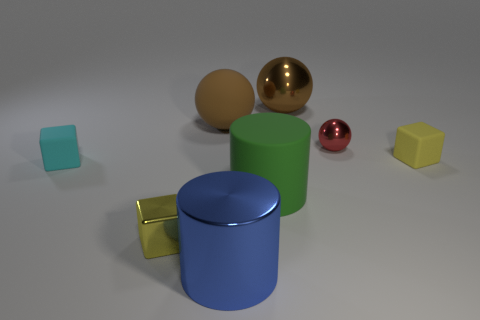Is there a gray metal thing?
Provide a short and direct response. No. There is a thing that is to the right of the blue metal object and in front of the tiny cyan block; what size is it?
Your response must be concise. Large. Is the number of shiny things in front of the big green cylinder greater than the number of tiny yellow rubber things behind the tiny red metallic thing?
Make the answer very short. Yes. What is the size of the rubber object that is the same color as the tiny shiny block?
Offer a terse response. Small. What is the color of the rubber cylinder?
Provide a succinct answer. Green. What color is the large object that is both behind the big metallic cylinder and in front of the small cyan rubber thing?
Your response must be concise. Green. The small metallic thing that is left of the big brown object that is on the right side of the big cylinder in front of the large matte cylinder is what color?
Provide a succinct answer. Yellow. What is the color of the metal cube that is the same size as the cyan object?
Provide a short and direct response. Yellow. There is a brown shiny thing to the left of the rubber block that is on the right side of the small yellow block on the left side of the red shiny thing; what is its shape?
Provide a short and direct response. Sphere. There is a thing that is the same color as the big rubber sphere; what shape is it?
Keep it short and to the point. Sphere. 